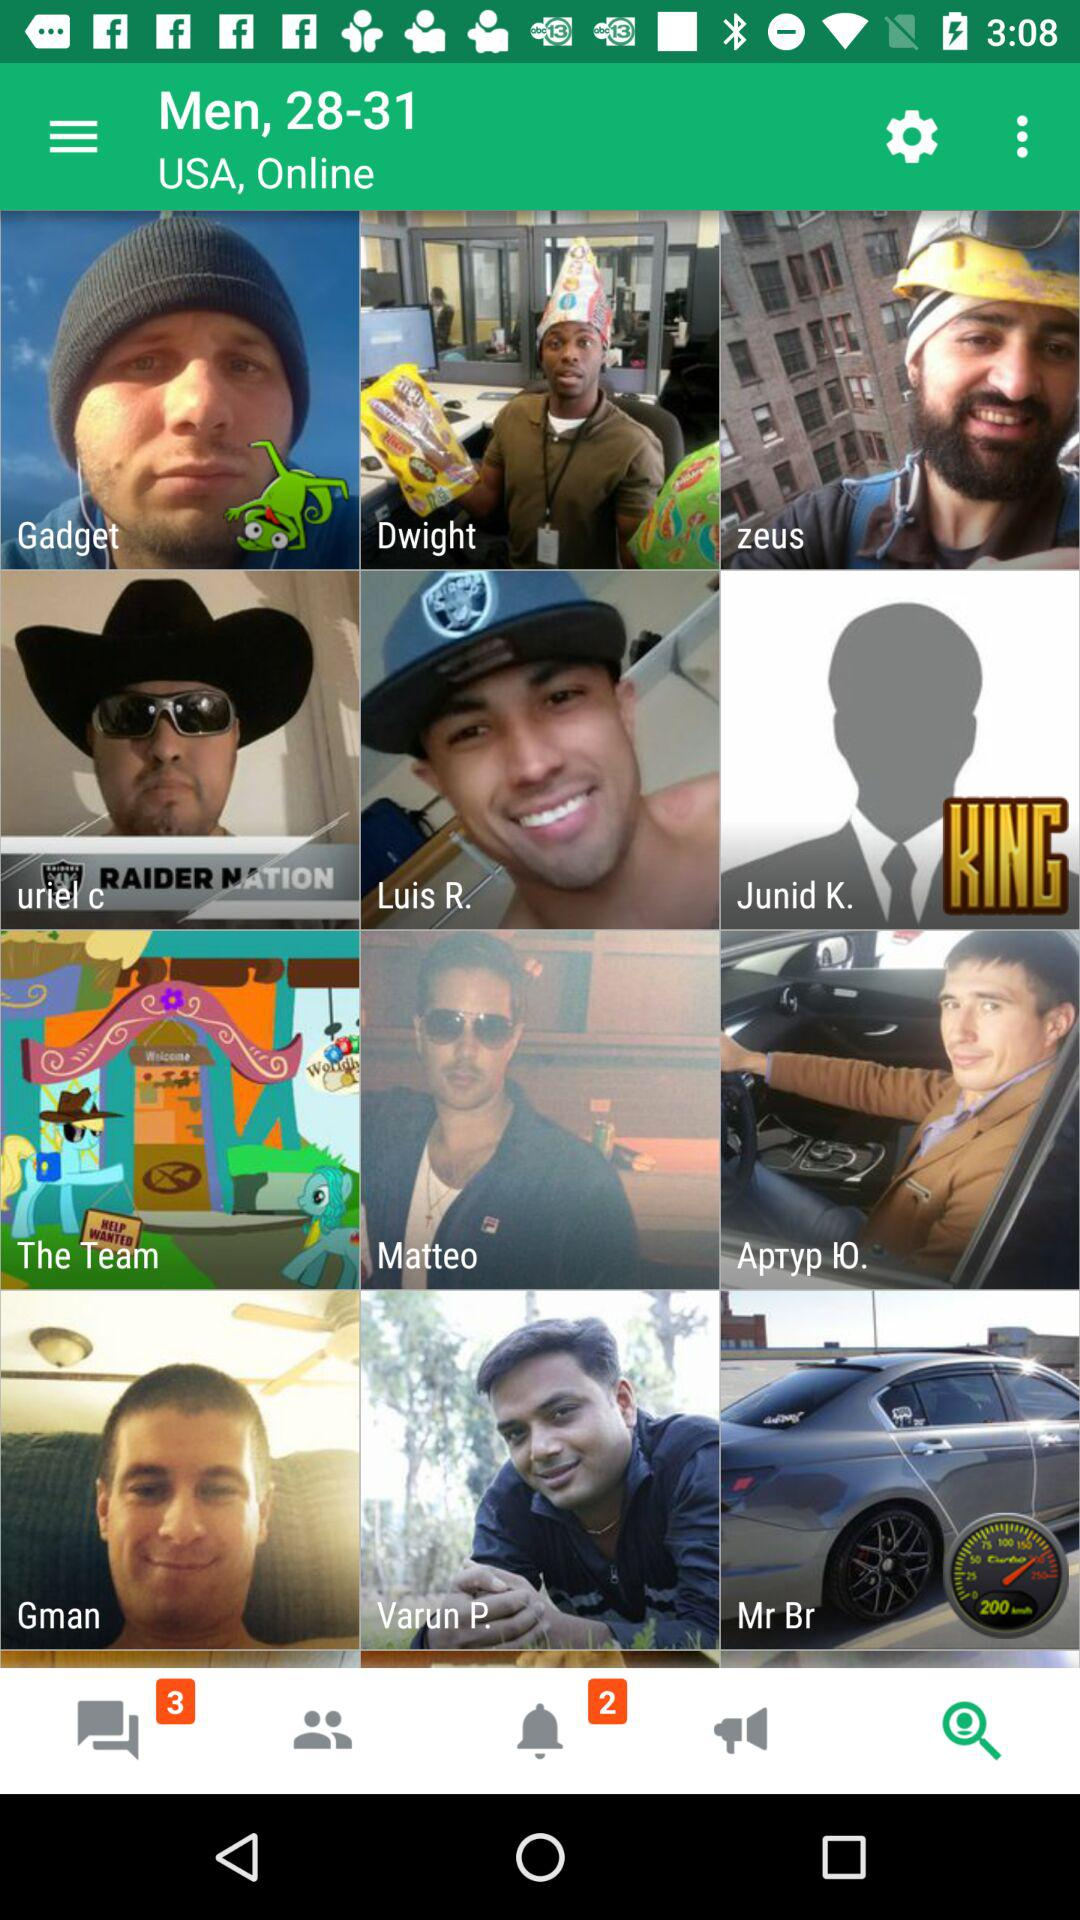How many unread chats are there? There are 3 unread chats. 